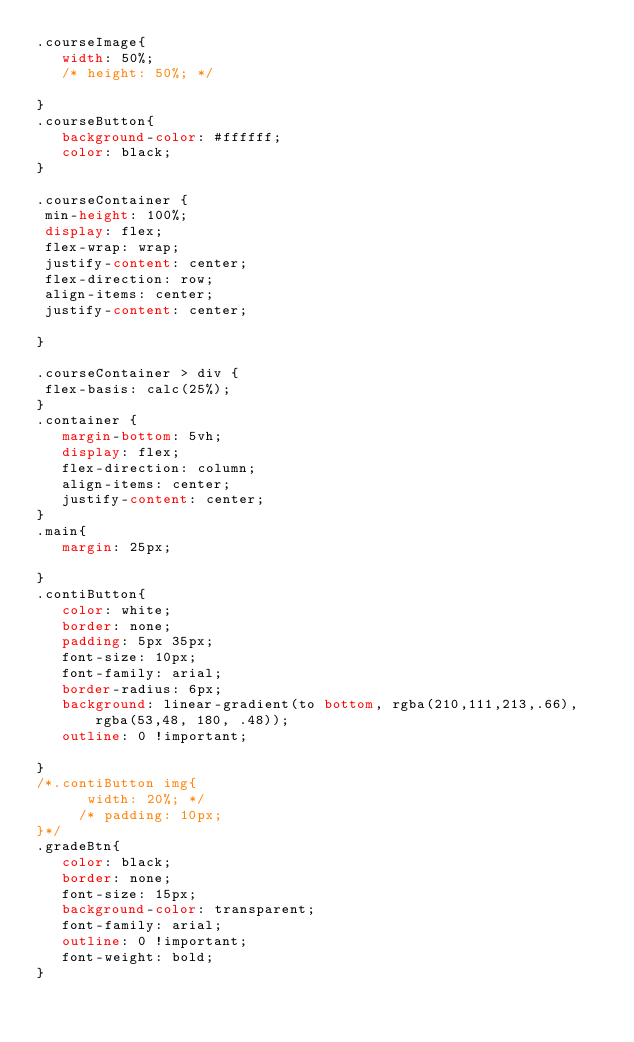<code> <loc_0><loc_0><loc_500><loc_500><_CSS_>.courseImage{
   width: 50%;
   /* height: 50%; */
   
}
.courseButton{
   background-color: #ffffff;
   color: black;
}

.courseContainer {
 min-height: 100%;
 display: flex;
 flex-wrap: wrap;
 justify-content: center;
 flex-direction: row;
 align-items: center;
 justify-content: center;

}

.courseContainer > div {
 flex-basis: calc(25%);
}
.container {
   margin-bottom: 5vh;
   display: flex;
   flex-direction: column;
   align-items: center;
   justify-content: center;
}
.main{
   margin: 25px;
   
}
.contiButton{
   color: white;
   border: none;
   padding: 5px 35px;
   font-size: 10px;
   font-family: arial;
   border-radius: 6px;
   background: linear-gradient(to bottom, rgba(210,111,213,.66),rgba(53,48, 180, .48));
   outline: 0 !important;
   
}
/*.contiButton img{
      width: 20%; */
     /* padding: 10px; 
}*/
.gradeBtn{
   color: black;
   border: none;
   font-size: 15px;
   background-color: transparent;
   font-family: arial;
   outline: 0 !important;
   font-weight: bold;
}</code> 